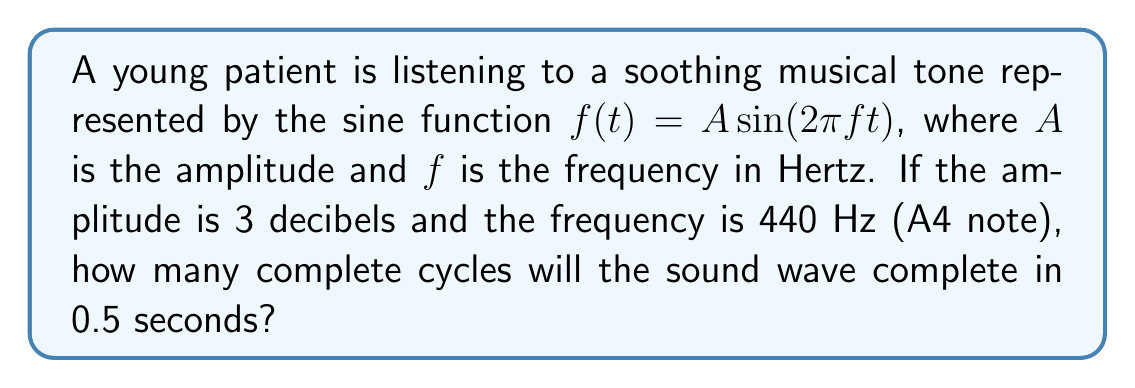Can you solve this math problem? Let's approach this step-by-step:

1) The general form of a sine wave is given by:
   $f(t) = A \sin(2\pi ft)$

2) We're given:
   - Amplitude $A = 3$ decibels (not needed for this calculation)
   - Frequency $f = 440$ Hz
   - Time $t = 0.5$ seconds

3) To find the number of complete cycles, we need to calculate how many times the sine function completes a full $2\pi$ radians in 0.5 seconds.

4) In one second, the wave completes $f$ cycles. So in $t$ seconds, it completes $f * t$ cycles.

5) Number of cycles = Frequency * Time
   $$\text{Cycles} = f * t = 440 * 0.5 = 220$$

Therefore, in 0.5 seconds, the sound wave will complete 220 cycles.
Answer: 220 cycles 